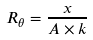<formula> <loc_0><loc_0><loc_500><loc_500>R _ { \theta } = \frac { x } { A \times k }</formula> 